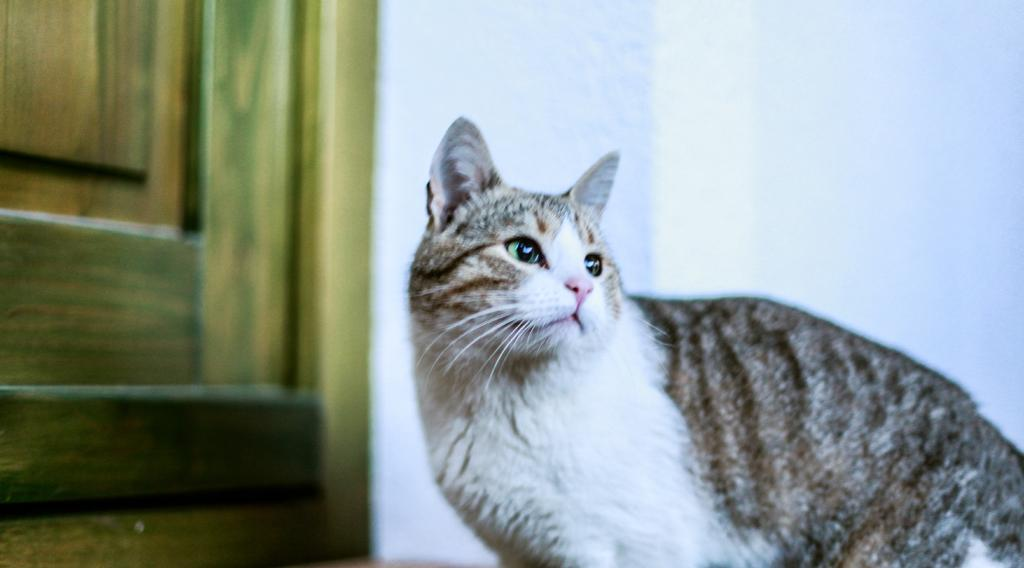What animal is present in the image? There is a cat in the image. What is the cat doing in the image? The cat is standing and looking at something. What can be seen in the background of the image? There is a wall and a door visible in the background of the image. What type of bead is the cat playing with in the image? There is no bead present in the image, and the cat is not playing with anything. 